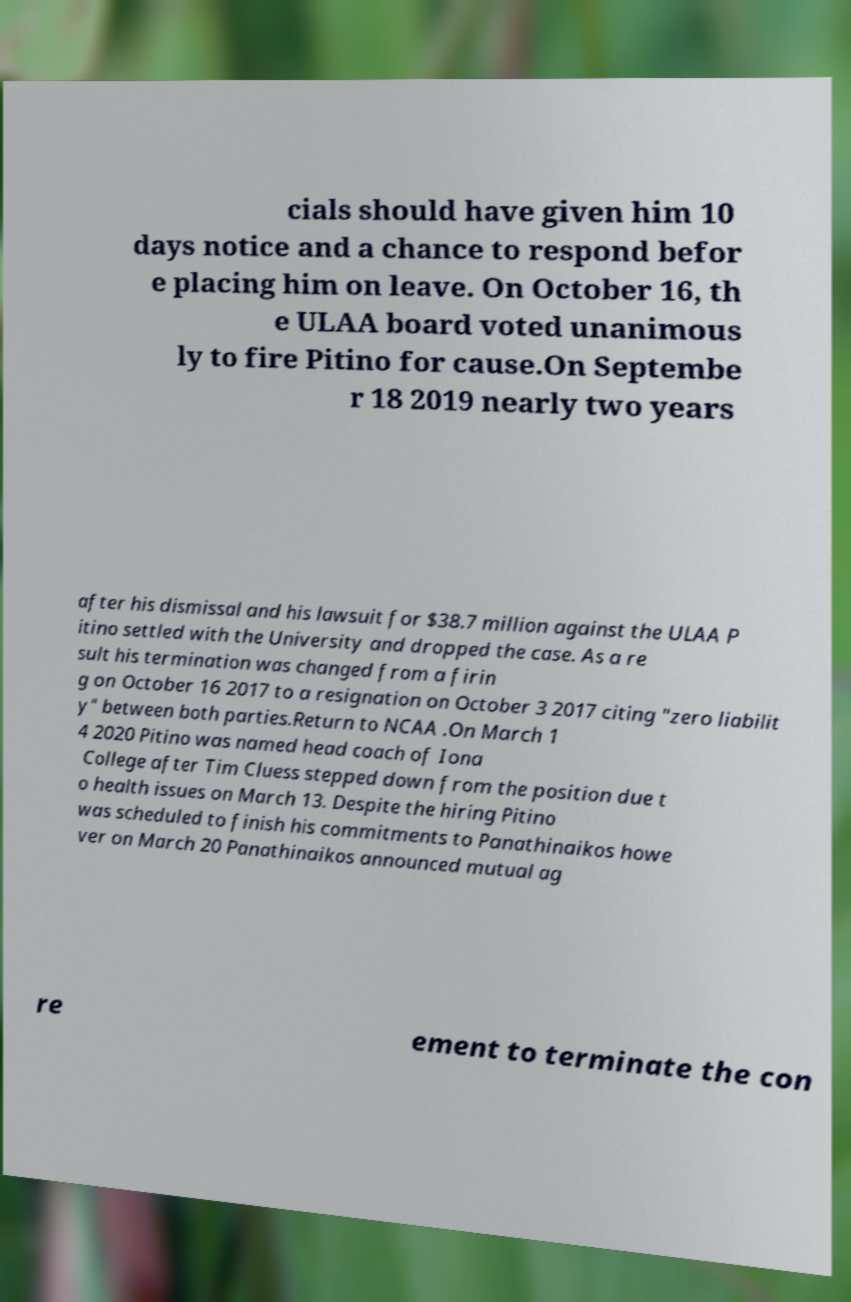What messages or text are displayed in this image? I need them in a readable, typed format. cials should have given him 10 days notice and a chance to respond befor e placing him on leave. On October 16, th e ULAA board voted unanimous ly to fire Pitino for cause.On Septembe r 18 2019 nearly two years after his dismissal and his lawsuit for $38.7 million against the ULAA P itino settled with the University and dropped the case. As a re sult his termination was changed from a firin g on October 16 2017 to a resignation on October 3 2017 citing "zero liabilit y" between both parties.Return to NCAA .On March 1 4 2020 Pitino was named head coach of Iona College after Tim Cluess stepped down from the position due t o health issues on March 13. Despite the hiring Pitino was scheduled to finish his commitments to Panathinaikos howe ver on March 20 Panathinaikos announced mutual ag re ement to terminate the con 